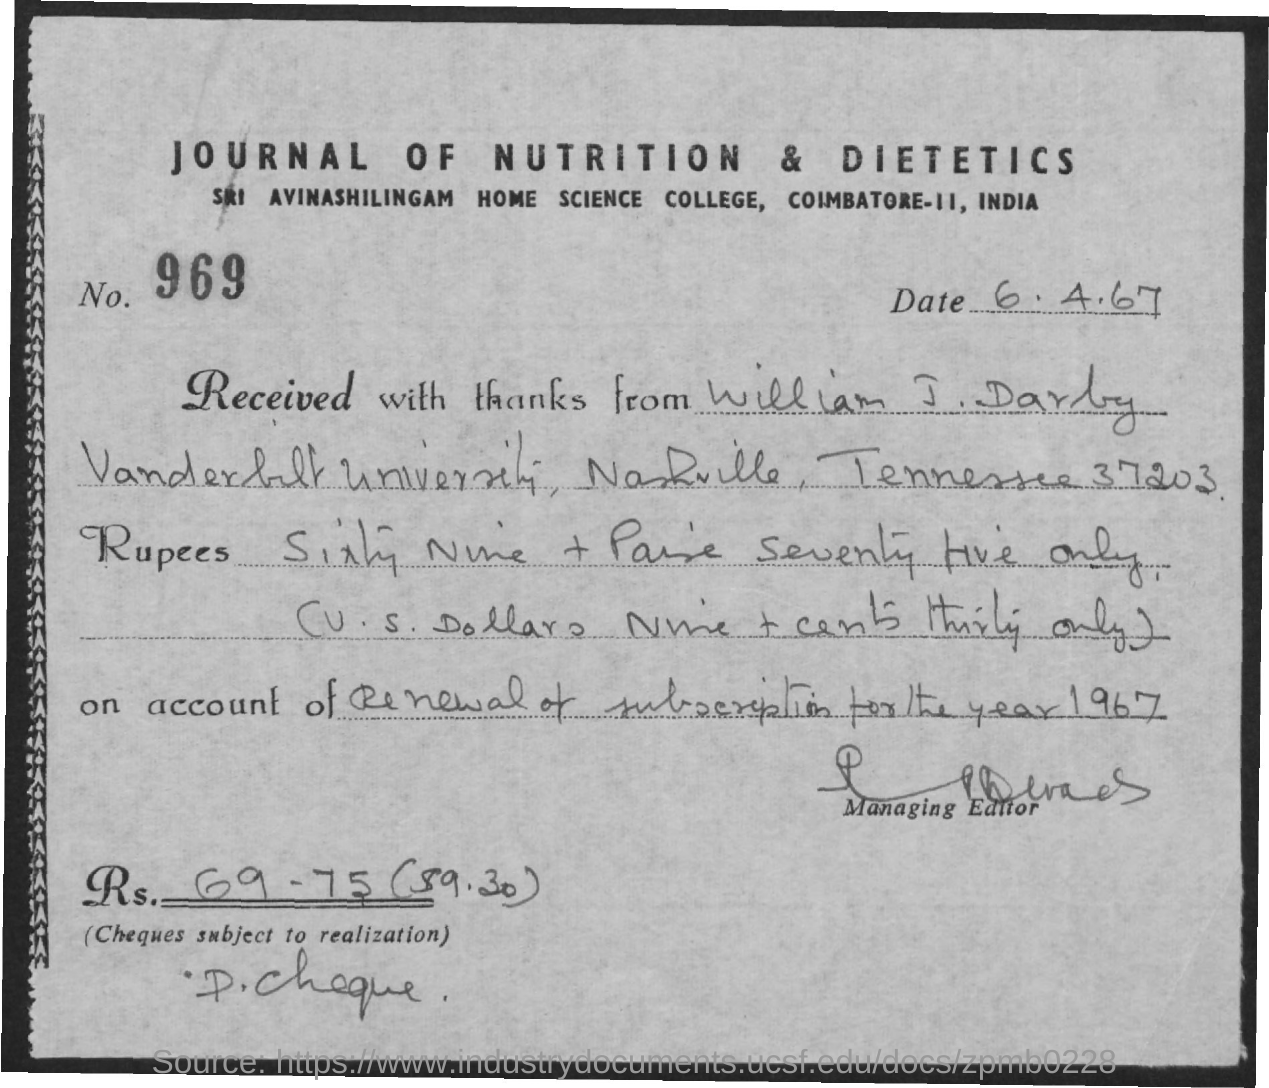Highlight a few significant elements in this photo. The check amount in digits is Rs. 69.75, and it represents Rs. 69.75 in Indian currency. This amount is equivalent to approximately $9.30 in the United States. The date mentioned in the document is 6 April 1967. The number mentioned in the document is 969. The header of the document mentions the journal "Journal of Nutrition & Dietetics. 